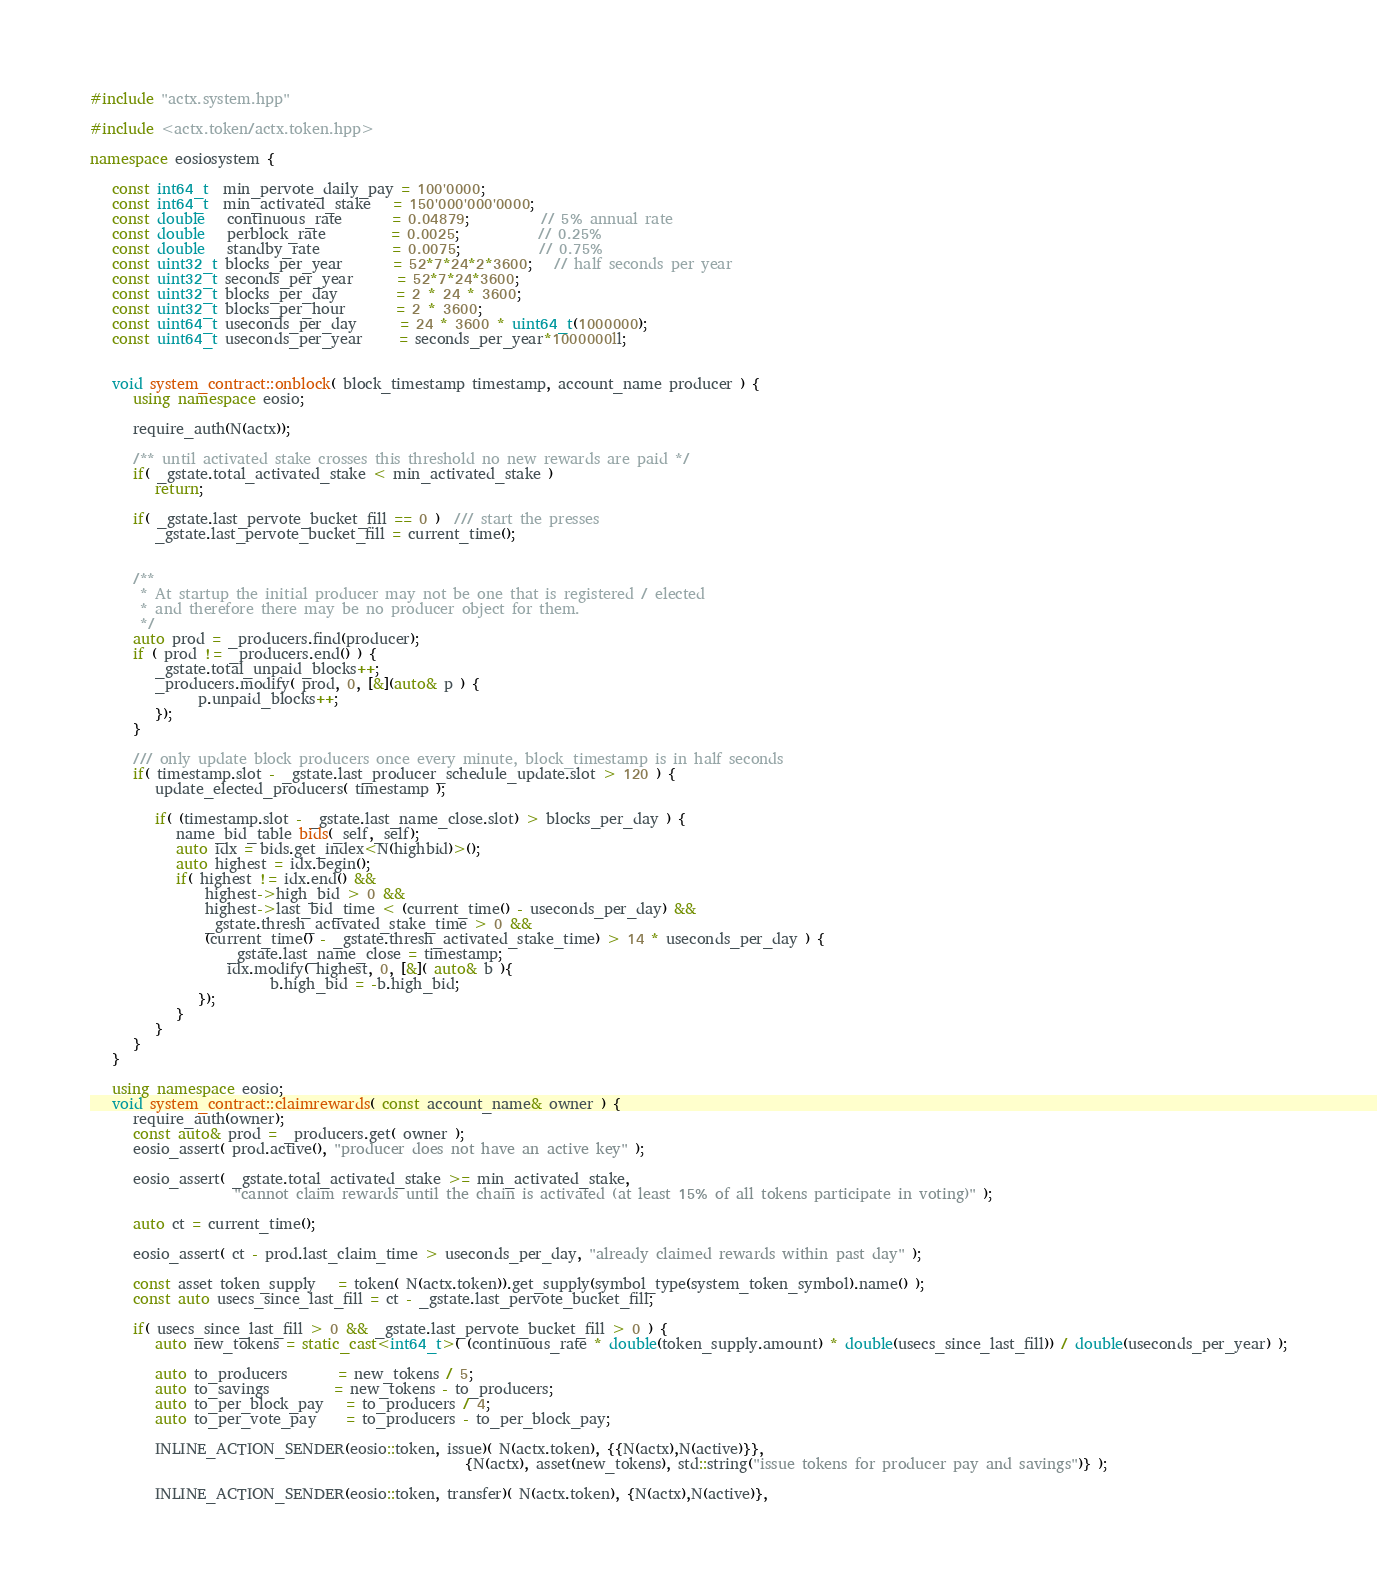<code> <loc_0><loc_0><loc_500><loc_500><_C++_>#include "actx.system.hpp"

#include <actx.token/actx.token.hpp>

namespace eosiosystem {

   const int64_t  min_pervote_daily_pay = 100'0000;
   const int64_t  min_activated_stake   = 150'000'000'0000;
   const double   continuous_rate       = 0.04879;          // 5% annual rate
   const double   perblock_rate         = 0.0025;           // 0.25%
   const double   standby_rate          = 0.0075;           // 0.75%
   const uint32_t blocks_per_year       = 52*7*24*2*3600;   // half seconds per year
   const uint32_t seconds_per_year      = 52*7*24*3600;
   const uint32_t blocks_per_day        = 2 * 24 * 3600;
   const uint32_t blocks_per_hour       = 2 * 3600;
   const uint64_t useconds_per_day      = 24 * 3600 * uint64_t(1000000);
   const uint64_t useconds_per_year     = seconds_per_year*1000000ll;


   void system_contract::onblock( block_timestamp timestamp, account_name producer ) {
      using namespace eosio;

      require_auth(N(actx));

      /** until activated stake crosses this threshold no new rewards are paid */
      if( _gstate.total_activated_stake < min_activated_stake )
         return;

      if( _gstate.last_pervote_bucket_fill == 0 )  /// start the presses
         _gstate.last_pervote_bucket_fill = current_time();


      /**
       * At startup the initial producer may not be one that is registered / elected
       * and therefore there may be no producer object for them.
       */
      auto prod = _producers.find(producer);
      if ( prod != _producers.end() ) {
         _gstate.total_unpaid_blocks++;
         _producers.modify( prod, 0, [&](auto& p ) {
               p.unpaid_blocks++;
         });
      }

      /// only update block producers once every minute, block_timestamp is in half seconds
      if( timestamp.slot - _gstate.last_producer_schedule_update.slot > 120 ) {
         update_elected_producers( timestamp );

         if( (timestamp.slot - _gstate.last_name_close.slot) > blocks_per_day ) {
            name_bid_table bids(_self,_self);
            auto idx = bids.get_index<N(highbid)>();
            auto highest = idx.begin();
            if( highest != idx.end() &&
                highest->high_bid > 0 &&
                highest->last_bid_time < (current_time() - useconds_per_day) &&
                _gstate.thresh_activated_stake_time > 0 &&
                (current_time() - _gstate.thresh_activated_stake_time) > 14 * useconds_per_day ) {
                   _gstate.last_name_close = timestamp;
                   idx.modify( highest, 0, [&]( auto& b ){
                         b.high_bid = -b.high_bid;
               });
            }
         }
      }
   }

   using namespace eosio;
   void system_contract::claimrewards( const account_name& owner ) {
      require_auth(owner);
      const auto& prod = _producers.get( owner );
      eosio_assert( prod.active(), "producer does not have an active key" );

      eosio_assert( _gstate.total_activated_stake >= min_activated_stake,
                    "cannot claim rewards until the chain is activated (at least 15% of all tokens participate in voting)" );

      auto ct = current_time();

      eosio_assert( ct - prod.last_claim_time > useconds_per_day, "already claimed rewards within past day" );

      const asset token_supply   = token( N(actx.token)).get_supply(symbol_type(system_token_symbol).name() );
      const auto usecs_since_last_fill = ct - _gstate.last_pervote_bucket_fill;

      if( usecs_since_last_fill > 0 && _gstate.last_pervote_bucket_fill > 0 ) {
         auto new_tokens = static_cast<int64_t>( (continuous_rate * double(token_supply.amount) * double(usecs_since_last_fill)) / double(useconds_per_year) );

         auto to_producers       = new_tokens / 5;
         auto to_savings         = new_tokens - to_producers;
         auto to_per_block_pay   = to_producers / 4;
         auto to_per_vote_pay    = to_producers - to_per_block_pay;

         INLINE_ACTION_SENDER(eosio::token, issue)( N(actx.token), {{N(actx),N(active)}},
                                                    {N(actx), asset(new_tokens), std::string("issue tokens for producer pay and savings")} );

         INLINE_ACTION_SENDER(eosio::token, transfer)( N(actx.token), {N(actx),N(active)},</code> 